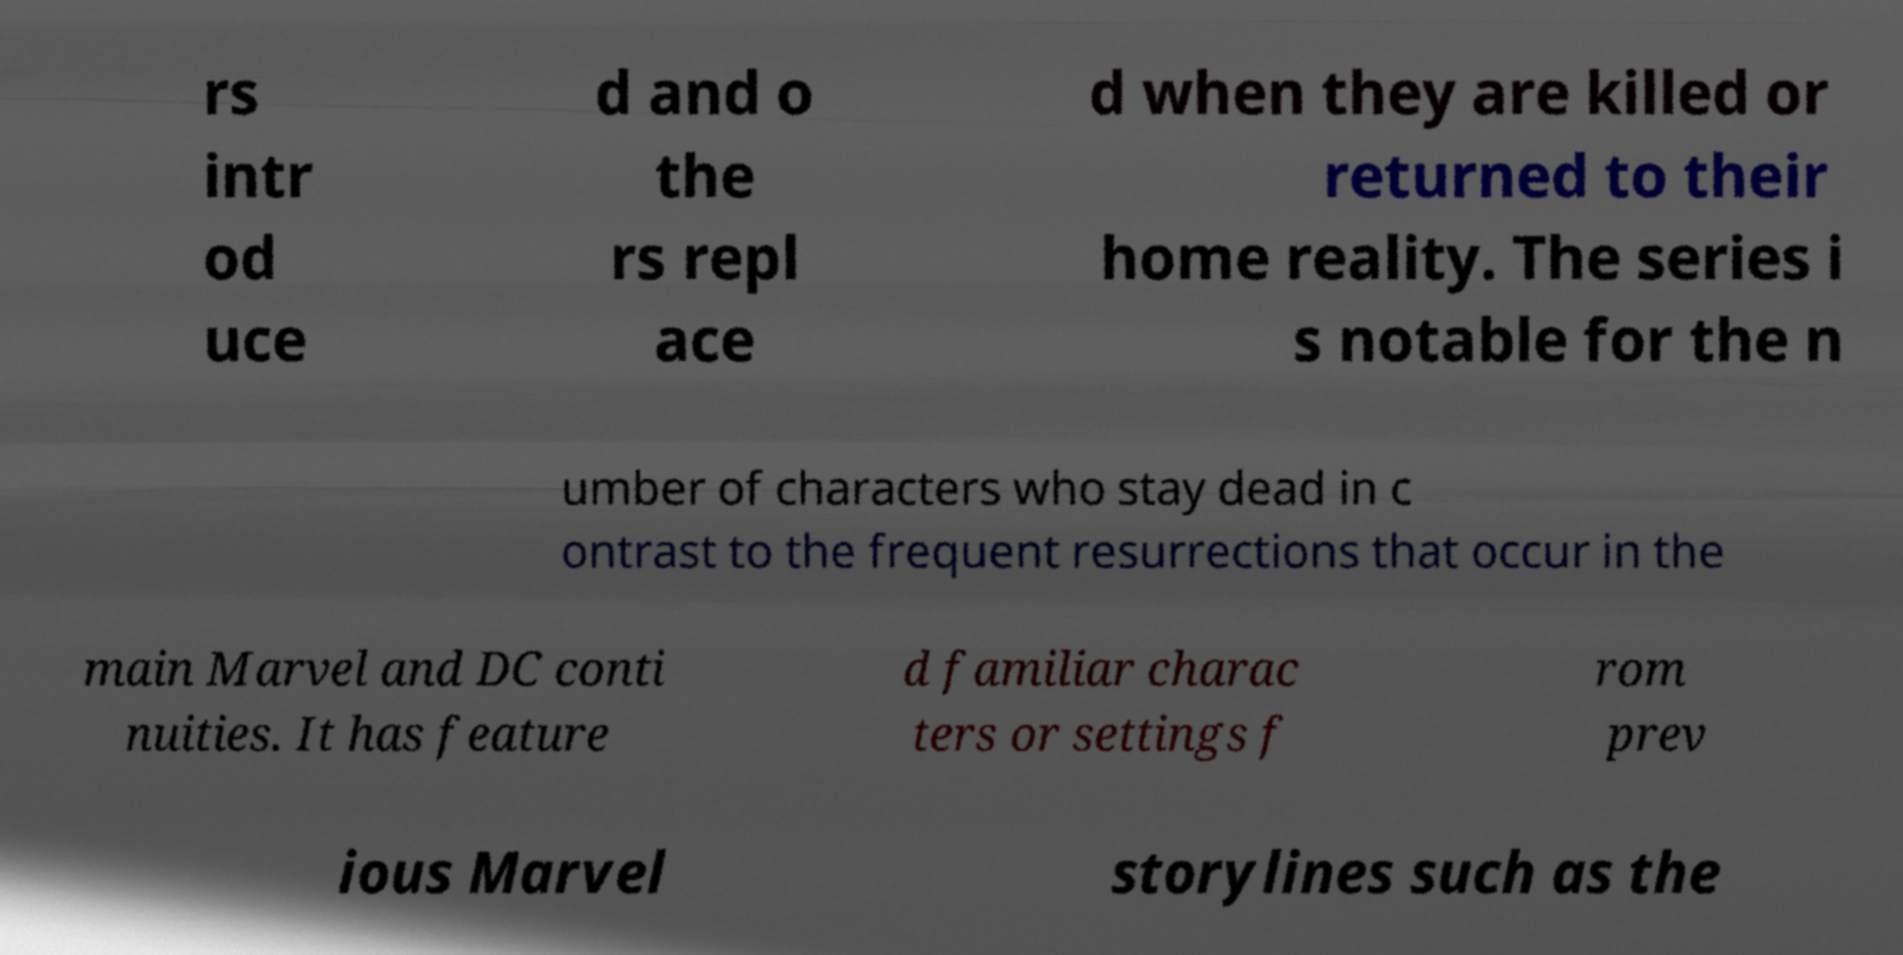Please identify and transcribe the text found in this image. rs intr od uce d and o the rs repl ace d when they are killed or returned to their home reality. The series i s notable for the n umber of characters who stay dead in c ontrast to the frequent resurrections that occur in the main Marvel and DC conti nuities. It has feature d familiar charac ters or settings f rom prev ious Marvel storylines such as the 